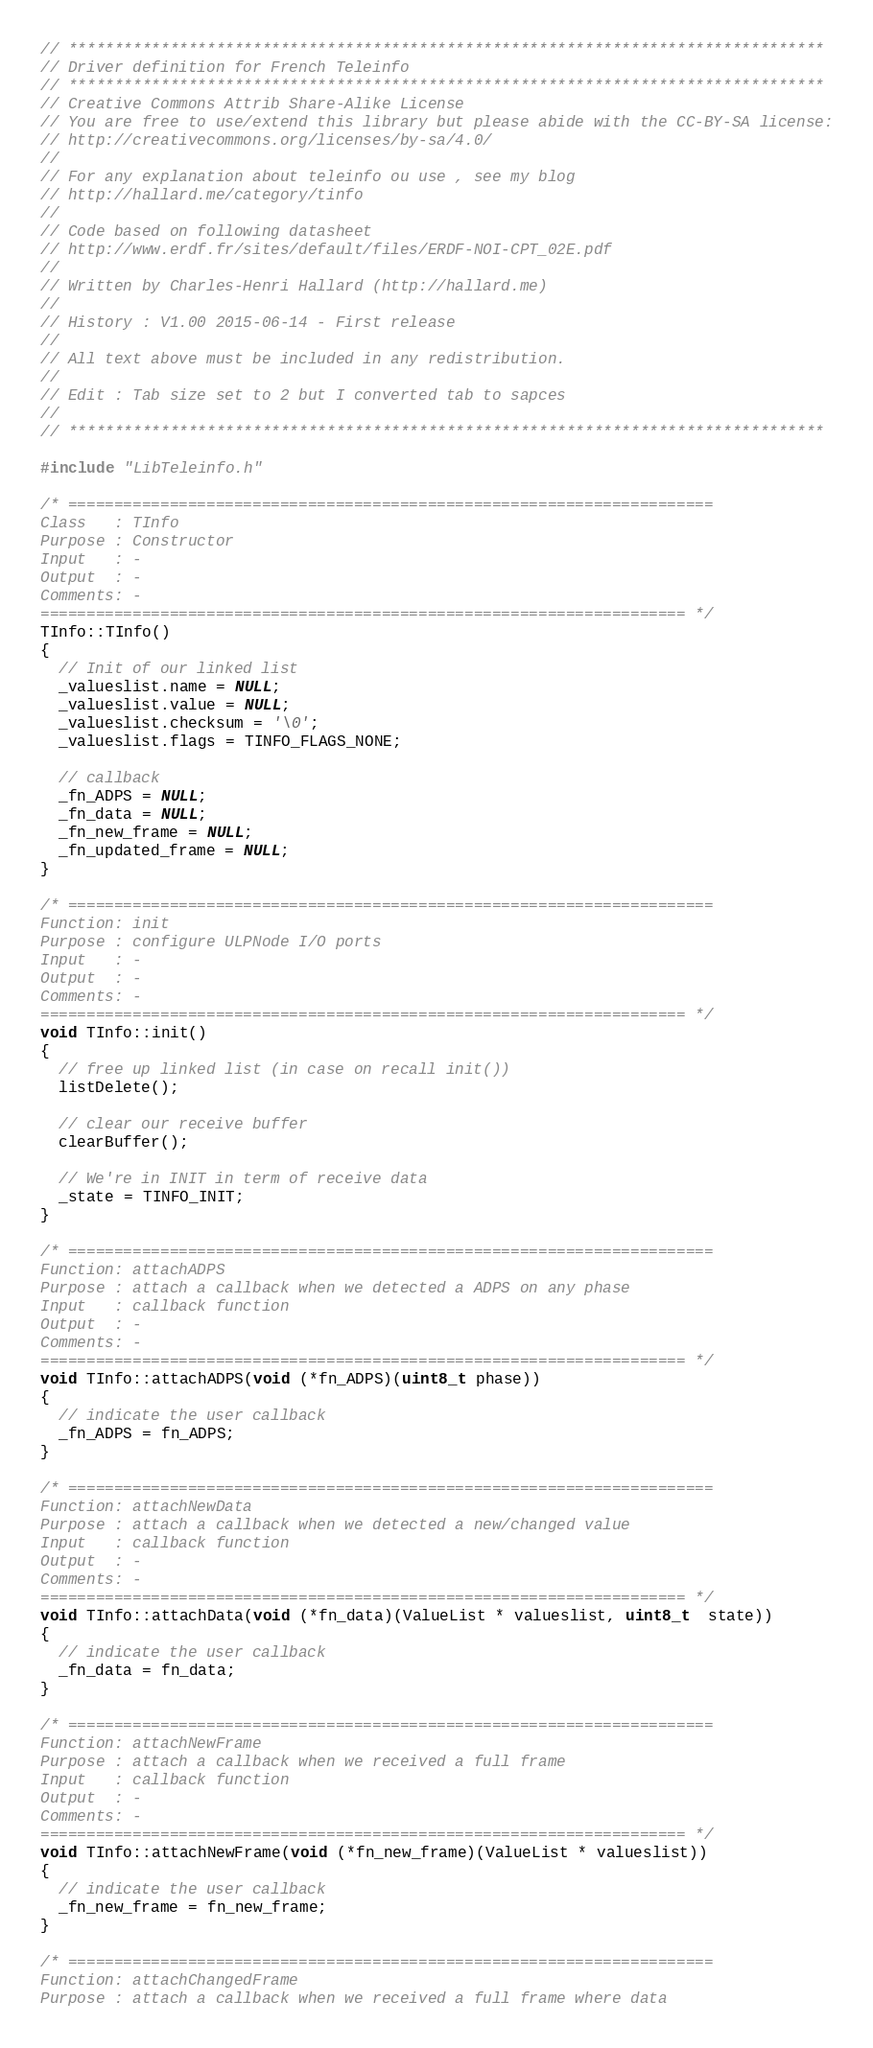<code> <loc_0><loc_0><loc_500><loc_500><_C++_>// **********************************************************************************
// Driver definition for French Teleinfo
// **********************************************************************************
// Creative Commons Attrib Share-Alike License
// You are free to use/extend this library but please abide with the CC-BY-SA license:
// http://creativecommons.org/licenses/by-sa/4.0/
//
// For any explanation about teleinfo ou use , see my blog
// http://hallard.me/category/tinfo
//
// Code based on following datasheet
// http://www.erdf.fr/sites/default/files/ERDF-NOI-CPT_02E.pdf
//
// Written by Charles-Henri Hallard (http://hallard.me)
//
// History : V1.00 2015-06-14 - First release
//
// All text above must be included in any redistribution.
//
// Edit : Tab size set to 2 but I converted tab to sapces
//
// **********************************************************************************

#include "LibTeleinfo.h" 

/* ======================================================================
Class   : TInfo
Purpose : Constructor
Input   : -
Output  : -
Comments: -
====================================================================== */
TInfo::TInfo()
{
  // Init of our linked list
  _valueslist.name = NULL;
  _valueslist.value = NULL;
  _valueslist.checksum = '\0';
  _valueslist.flags = TINFO_FLAGS_NONE;

  // callback
  _fn_ADPS = NULL;
  _fn_data = NULL;   
  _fn_new_frame = NULL;   
  _fn_updated_frame = NULL;   
}

/* ======================================================================
Function: init
Purpose : configure ULPNode I/O ports 
Input   : -
Output  : -
Comments: - 
====================================================================== */
void TInfo::init()
{
  // free up linked list (in case on recall init())
  listDelete();

  // clear our receive buffer
  clearBuffer();

  // We're in INIT in term of receive data
  _state = TINFO_INIT;
}

/* ======================================================================
Function: attachADPS 
Purpose : attach a callback when we detected a ADPS on any phase
Input   : callback function
Output  : - 
Comments: -
====================================================================== */
void TInfo::attachADPS(void (*fn_ADPS)(uint8_t phase))
{
  // indicate the user callback
  _fn_ADPS = fn_ADPS;   
}

/* ======================================================================
Function: attachNewData 
Purpose : attach a callback when we detected a new/changed value 
Input   : callback function
Output  : - 
Comments: -
====================================================================== */
void TInfo::attachData(void (*fn_data)(ValueList * valueslist, uint8_t  state))
{
  // indicate the user callback
  _fn_data = fn_data;   
}

/* ======================================================================
Function: attachNewFrame 
Purpose : attach a callback when we received a full frame
Input   : callback function
Output  : - 
Comments: -
====================================================================== */
void TInfo::attachNewFrame(void (*fn_new_frame)(ValueList * valueslist))
{
  // indicate the user callback
  _fn_new_frame = fn_new_frame;   
}

/* ======================================================================
Function: attachChangedFrame 
Purpose : attach a callback when we received a full frame where data</code> 